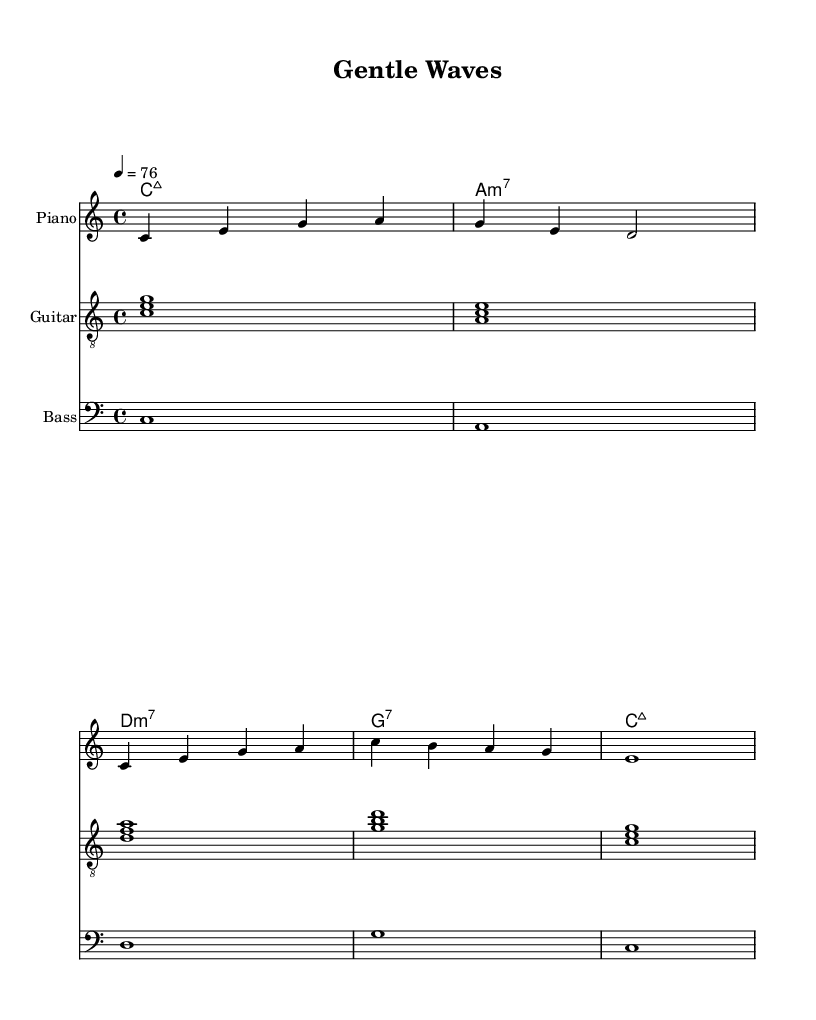What is the key signature of this music? The key signature is C major, which has no sharps or flats.
Answer: C major What is the time signature of this music? The time signature is found at the beginning of the staff and is marked as 4/4, indicating four beats per measure.
Answer: 4/4 What is the tempo marking of this piece? The tempo marking indicates the speed of the music. Here, it is notated as "4 = 76," meaning there are 76 quarter note beats per minute.
Answer: 76 How many measures are in the melody section? Counting the measures in the melody line gives a total of five distinct measures.
Answer: 5 What types of chords are predominantly used in this piece? The chords mostly consist of major and minor 7th chords, which are a common characteristic of bossa nova music.
Answer: Major and minor 7th chords What instrument is specified for the melody? The instrument designated for the melody is the Piano, indicated in the staff's instrument name.
Answer: Piano Which musical genre does this piece represent? The style of music can be identified by the rhythm, harmony, and instrumentation; it is characteristic of bossa nova.
Answer: Bossa nova 